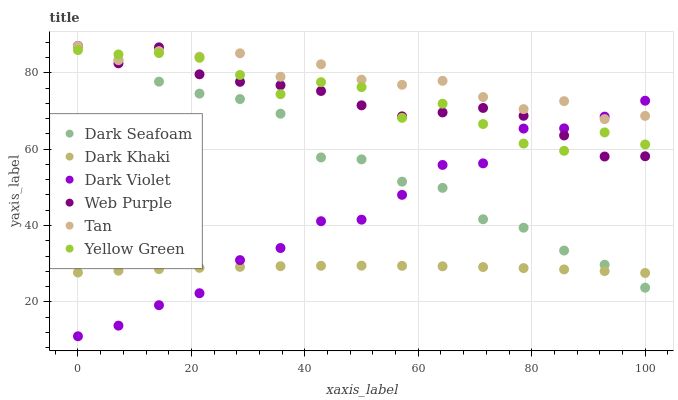Does Dark Khaki have the minimum area under the curve?
Answer yes or no. Yes. Does Tan have the maximum area under the curve?
Answer yes or no. Yes. Does Web Purple have the minimum area under the curve?
Answer yes or no. No. Does Web Purple have the maximum area under the curve?
Answer yes or no. No. Is Dark Khaki the smoothest?
Answer yes or no. Yes. Is Yellow Green the roughest?
Answer yes or no. Yes. Is Web Purple the smoothest?
Answer yes or no. No. Is Web Purple the roughest?
Answer yes or no. No. Does Dark Violet have the lowest value?
Answer yes or no. Yes. Does Web Purple have the lowest value?
Answer yes or no. No. Does Tan have the highest value?
Answer yes or no. Yes. Does Dark Violet have the highest value?
Answer yes or no. No. Is Dark Khaki less than Yellow Green?
Answer yes or no. Yes. Is Web Purple greater than Dark Khaki?
Answer yes or no. Yes. Does Dark Seafoam intersect Dark Violet?
Answer yes or no. Yes. Is Dark Seafoam less than Dark Violet?
Answer yes or no. No. Is Dark Seafoam greater than Dark Violet?
Answer yes or no. No. Does Dark Khaki intersect Yellow Green?
Answer yes or no. No. 